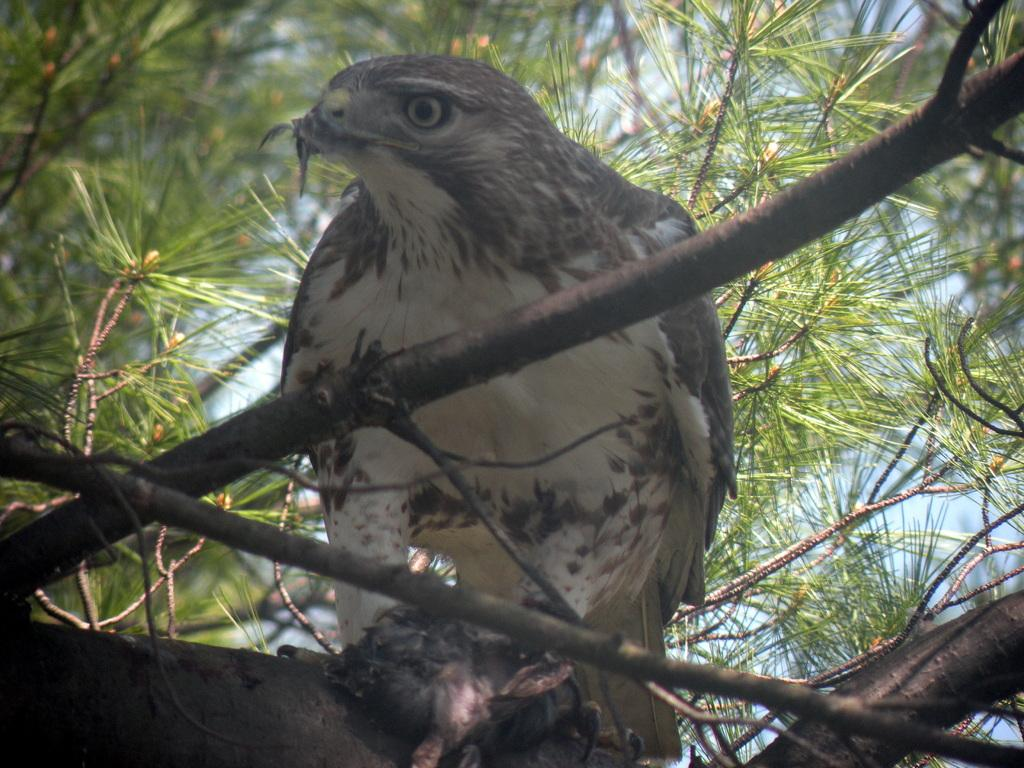What is located at the front of the image? There are stems of a tree in the front of the image. What can be seen in the center of the image? There is a bird sitting on a tree in the center of the image. What type of vegetation is visible in the background of the image? There are leaves visible in the background of the image. What type of prison can be seen in the background of the image? There is no prison present in the image; it features a bird sitting on a tree with leaves in the background. What type of vacation destination is depicted in the image? The image does not depict a vacation destination; it features a bird sitting on a tree with leaves in the background. 